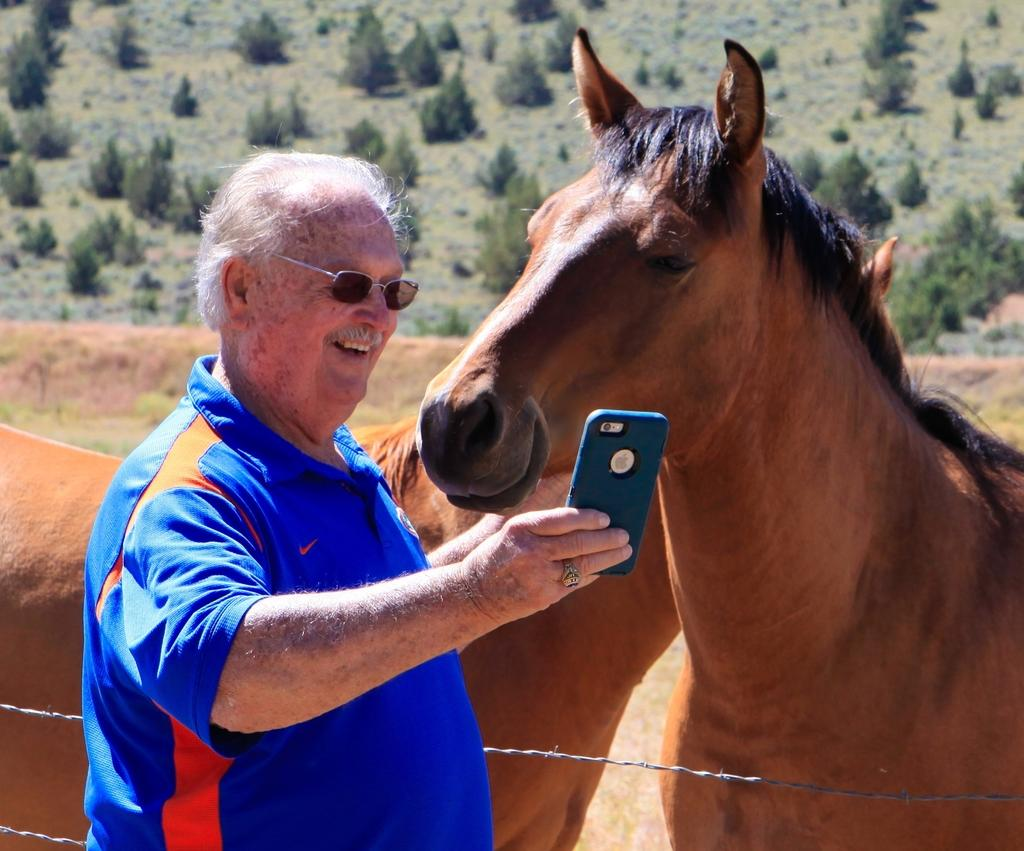Where was the image taken? The image was taken outdoors. What is the man in the image wearing? The man is wearing a blue t-shirt. What is the man holding in the image? The man is holding a mobile. What animals are behind the man in the image? There are two horses behind the man. What can be seen in the background of the image? Trees and a path are visible in the background. How many babies are sitting on the horses in the image? There are no babies present in the image, and the horses do not have any riders. What type of fruit can be seen hanging from the trees in the background? There is no fruit visible in the image; only trees and a path can be seen in the background. 